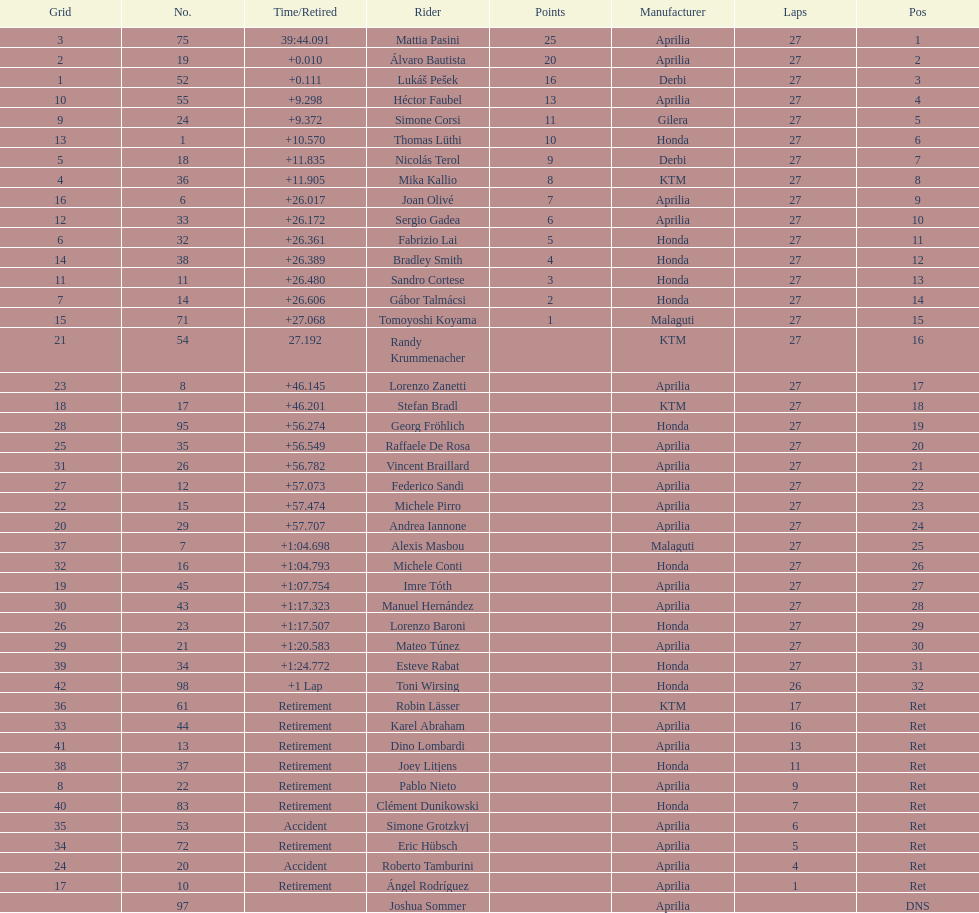Which cyclist finished first with 25 points? Mattia Pasini. 